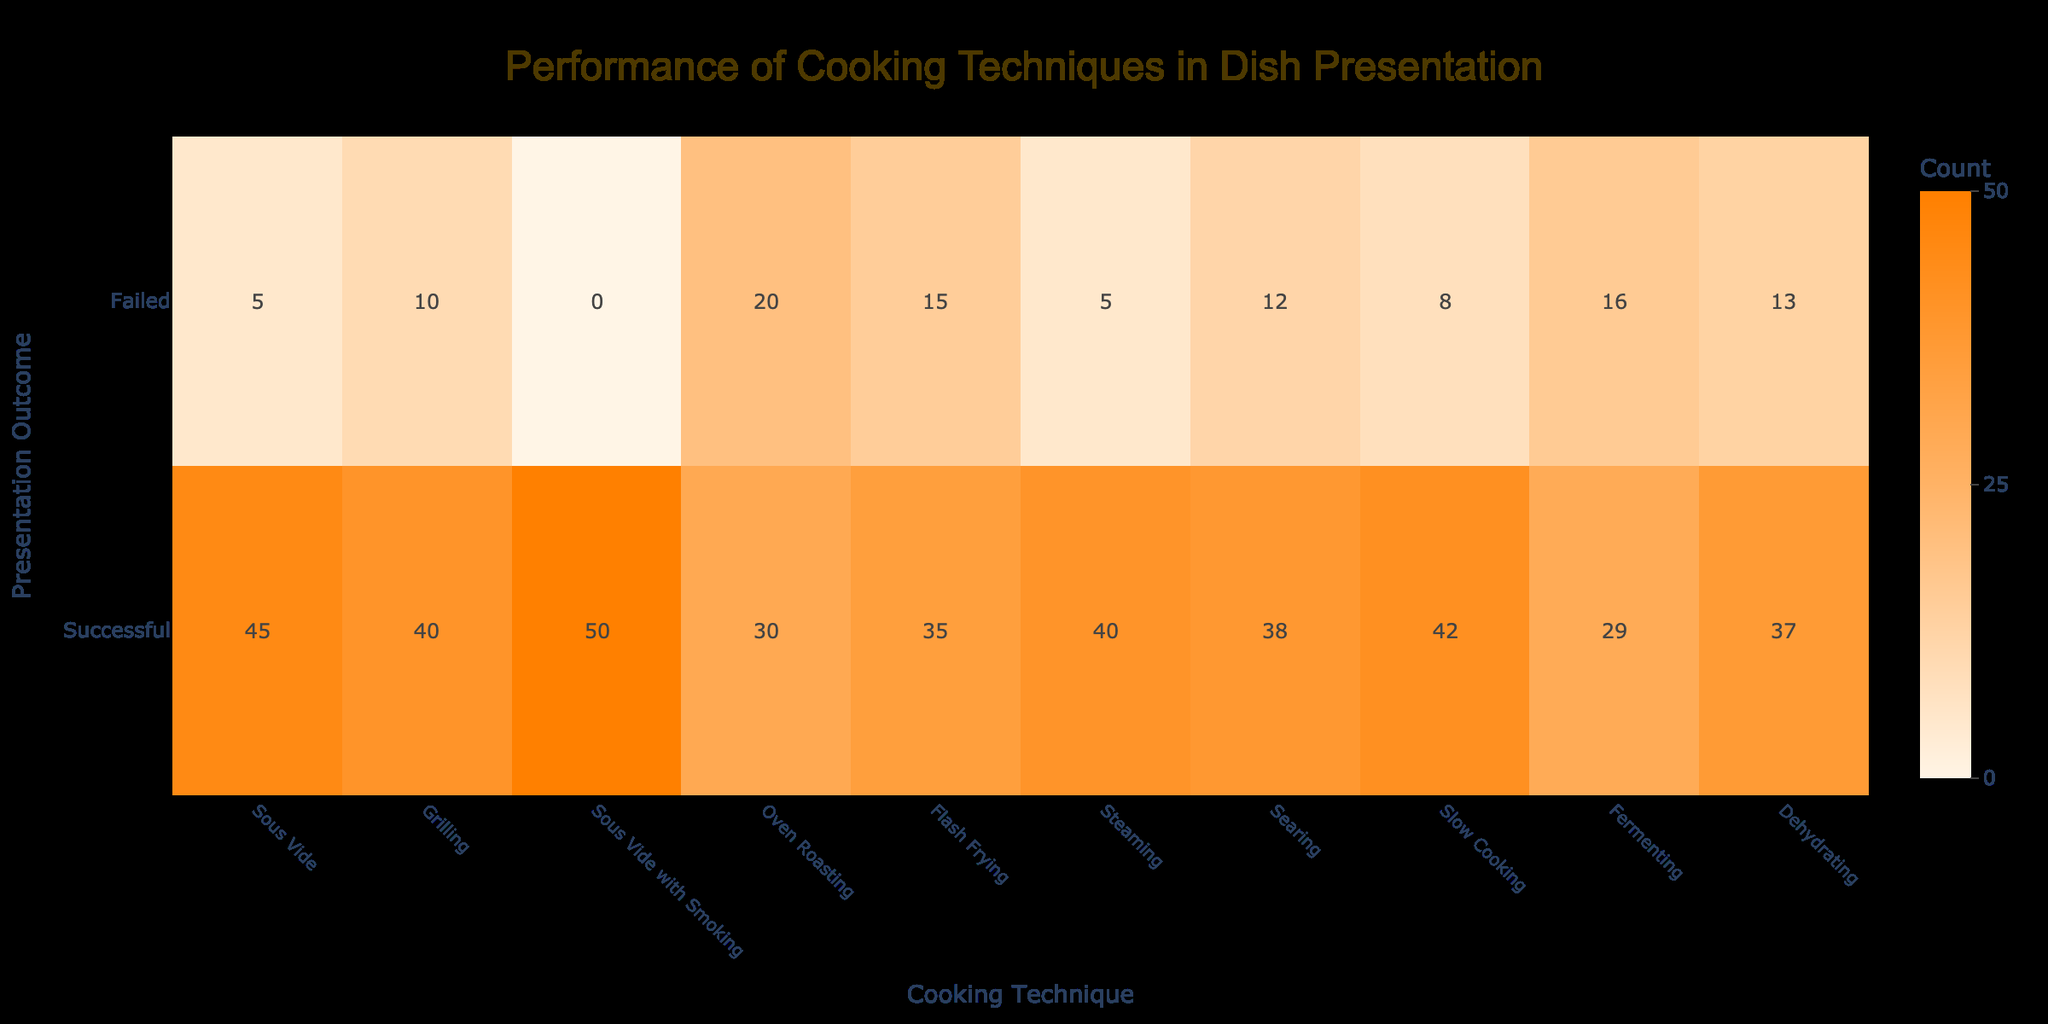What is the highest number of successful presentations among the cooking techniques? The highest number of successful presentations can be found by looking through the Successful Presentation column. The maximum value is 50, which corresponds to the cooking technique "Sous Vide with Smoking."
Answer: 50 Which cooking technique had the lowest number of failed presentations? By examining the Failed Presentation column, the lowest value is 0, indicating that "Sous Vide with Smoking" had no failed presentations.
Answer: Sous Vide with Smoking What is the average number of successful presentations across all techniques? To find the average, add all successful presentations: (45 + 40 + 50 + 30 + 35 + 40 + 38 + 42 + 29 + 37) =  436. There are 10 techniques, so the average is 436 / 10 = 43.6.
Answer: 43.6 Is it true that Grilling had more successful presentations than Oven Roasting? Comparing the Successful Presentation values, Grilling has 40 and Oven Roasting has 30. Since 40 is greater than 30, the statement is true.
Answer: Yes What is the total number of failed presentations for Sous Vide and Oven Roasting combined? Add the failed presentations of both techniques: Sous Vide has 5 and Oven Roasting has 20, so 5 + 20 = 25.
Answer: 25 Which cooking technique had the highest total of presentations (successful + failed)? To find the highest total, calculate the sum of successful and failed presentations for each technique and identify the maximum: Sous Vide with Smoking = 50, Grilling = 50, Sous Vide = 50, and so on. The highest total is 50 found in "Sous Vide with Smoking."
Answer: Sous Vide with Smoking What is the difference between the number of successful and failed presentations for Flash Frying? For Flash Frying, the number of successful presentations is 35 and failed presentations are 15. The difference is calculated as 35 - 15 = 20.
Answer: 20 How many cooking techniques had more failed presentations than successful ones? By analyzing the Failed and Successful Presentation columns, we see that the techniques with more failed presentations are Oven Roasting (20 failed, 30 successful) and Fermenting (16 failed, 29 successful). Both have more failed than successful presentations. Therefore, there are 2 techniques.
Answer: 2 What is the total number of successful presentations for techniques that involve Sous Vide? The techniques are "Sous Vide" (45) and "Sous Vide with Smoking" (50). The total is 45 + 50 = 95 for the successful presentations.
Answer: 95 